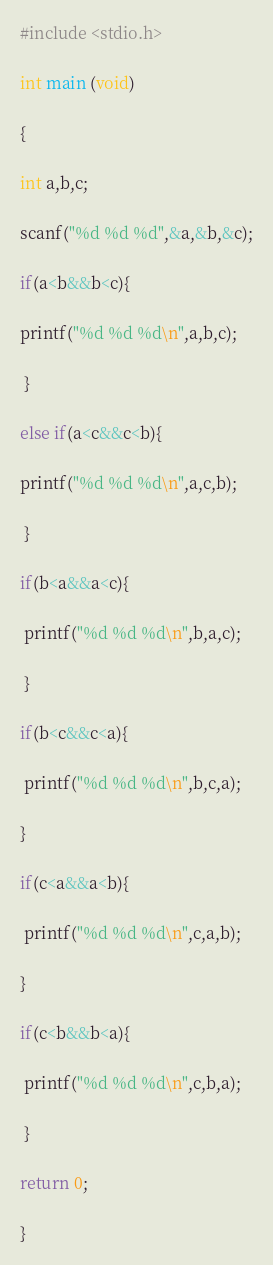<code> <loc_0><loc_0><loc_500><loc_500><_C_>#include <stdio.h>

int main (void)

{

int a,b,c;

scanf("%d %d %d",&a,&b,&c);

if(a<b&&b<c){

printf("%d %d %d\n",a,b,c);

 }

else if(a<c&&c<b){

printf("%d %d %d\n",a,c,b);

 }

if(b<a&&a<c){

 printf("%d %d %d\n",b,a,c);

 }

if(b<c&&c<a){

 printf("%d %d %d\n",b,c,a);

}

if(c<a&&a<b){

 printf("%d %d %d\n",c,a,b);

}

if(c<b&&b<a){

 printf("%d %d %d\n",c,b,a);

 }

return 0;

}</code> 